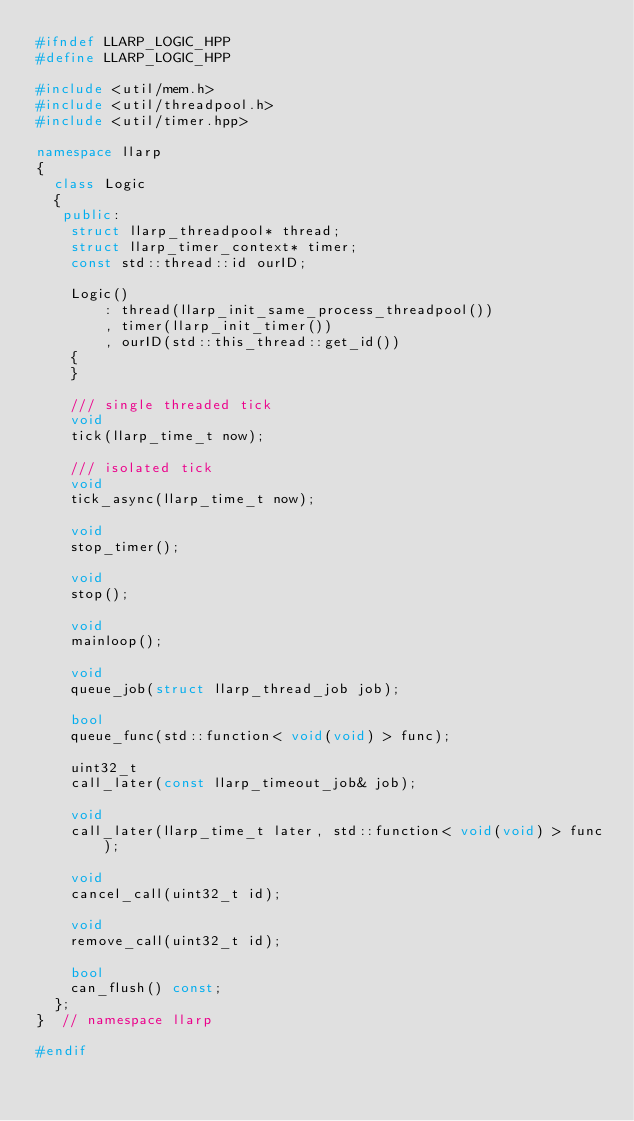Convert code to text. <code><loc_0><loc_0><loc_500><loc_500><_C++_>#ifndef LLARP_LOGIC_HPP
#define LLARP_LOGIC_HPP

#include <util/mem.h>
#include <util/threadpool.h>
#include <util/timer.hpp>

namespace llarp
{
  class Logic
  {
   public:
    struct llarp_threadpool* thread;
    struct llarp_timer_context* timer;
    const std::thread::id ourID;

    Logic()
        : thread(llarp_init_same_process_threadpool())
        , timer(llarp_init_timer())
        , ourID(std::this_thread::get_id())
    {
    }

    /// single threaded tick
    void
    tick(llarp_time_t now);

    /// isolated tick
    void
    tick_async(llarp_time_t now);

    void
    stop_timer();

    void
    stop();

    void
    mainloop();

    void
    queue_job(struct llarp_thread_job job);

    bool
    queue_func(std::function< void(void) > func);

    uint32_t
    call_later(const llarp_timeout_job& job);

    void
    call_later(llarp_time_t later, std::function< void(void) > func);

    void
    cancel_call(uint32_t id);

    void
    remove_call(uint32_t id);

    bool
    can_flush() const;
  };
}  // namespace llarp

#endif
</code> 